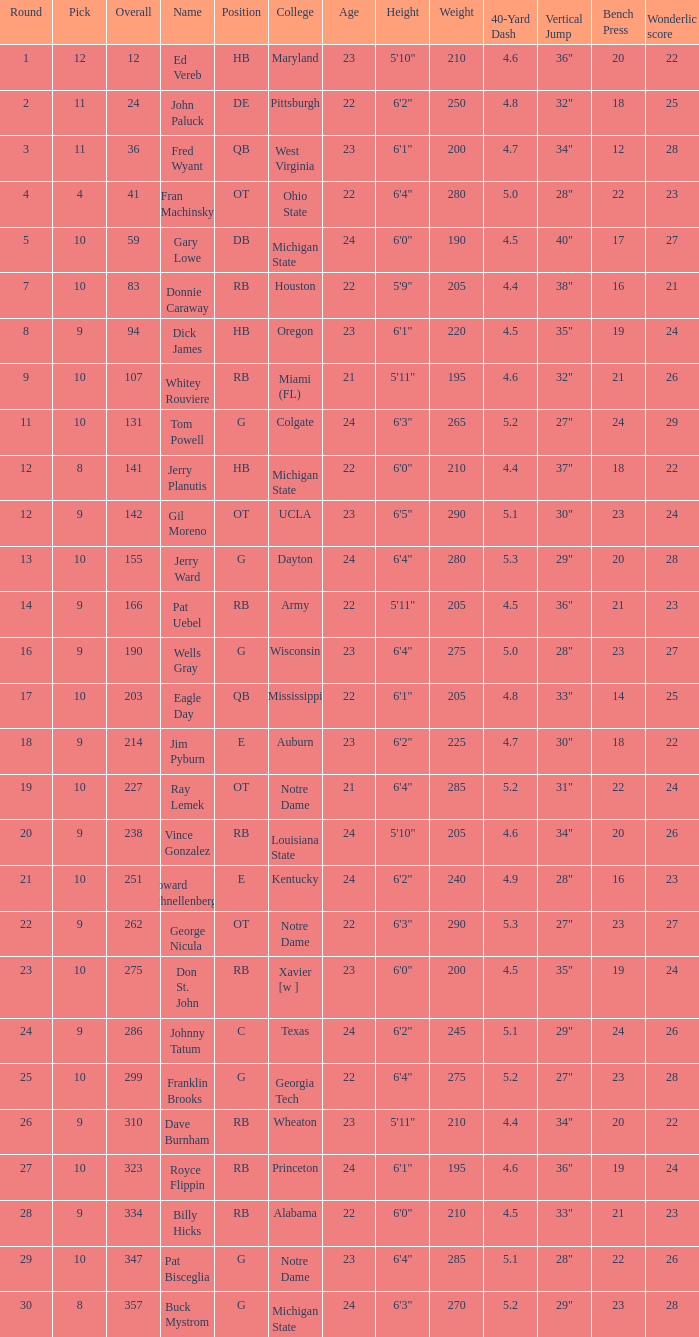What is the sum of rounds that has a pick of 9 and is named jim pyburn? 18.0. 